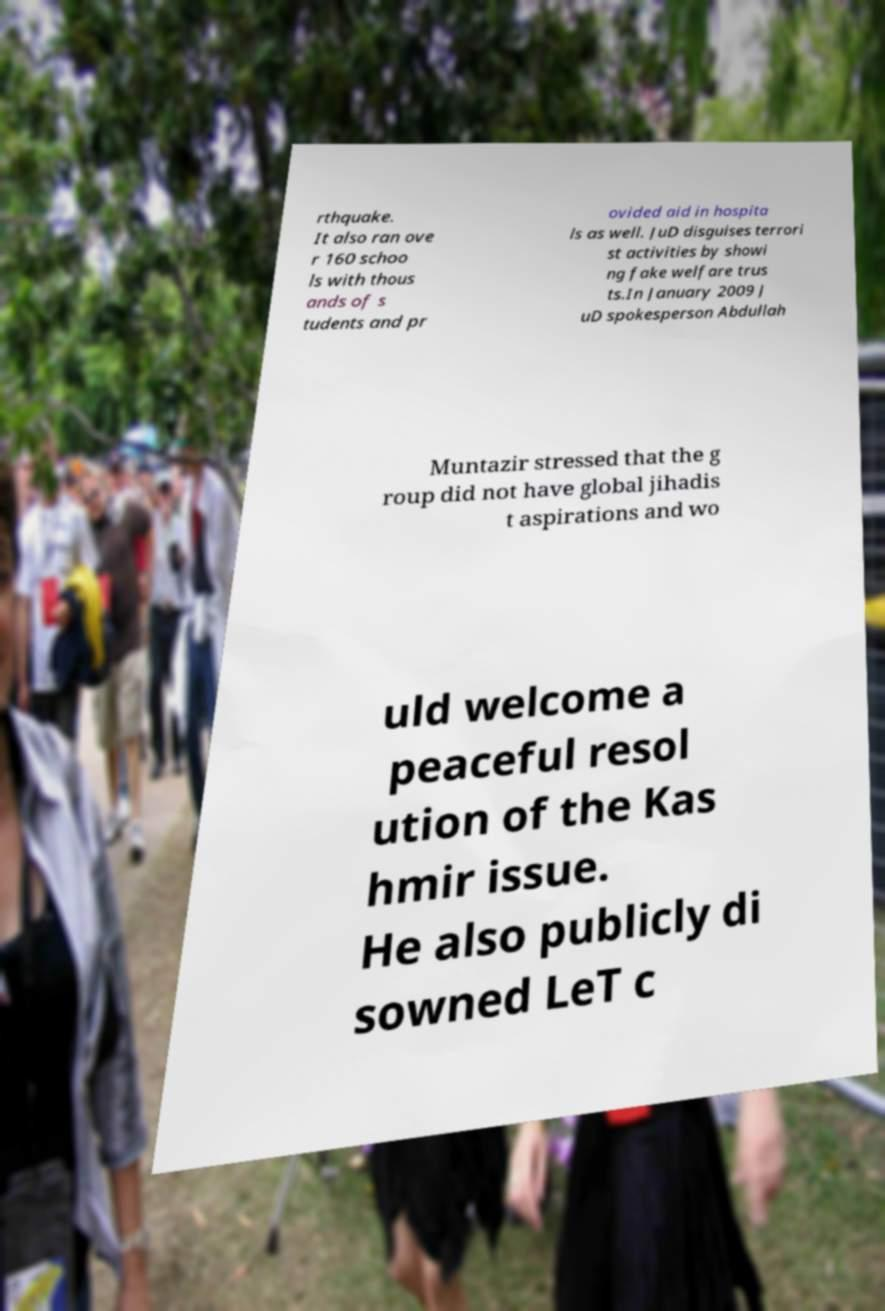Please read and relay the text visible in this image. What does it say? rthquake. It also ran ove r 160 schoo ls with thous ands of s tudents and pr ovided aid in hospita ls as well. JuD disguises terrori st activities by showi ng fake welfare trus ts.In January 2009 J uD spokesperson Abdullah Muntazir stressed that the g roup did not have global jihadis t aspirations and wo uld welcome a peaceful resol ution of the Kas hmir issue. He also publicly di sowned LeT c 